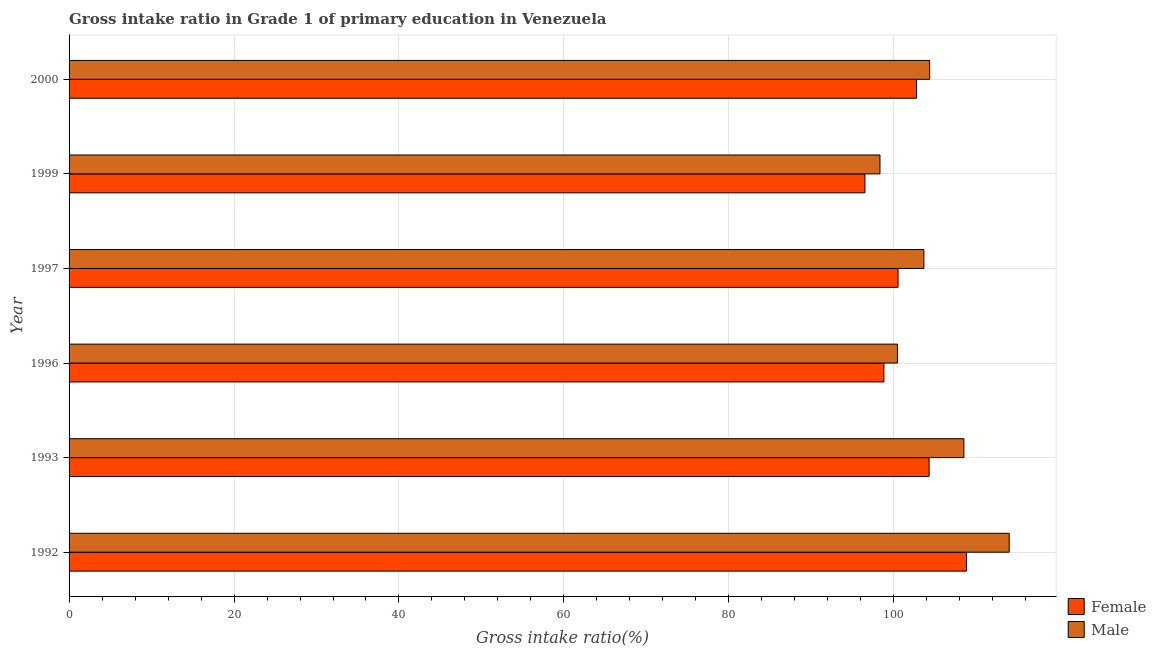How many different coloured bars are there?
Ensure brevity in your answer.  2. How many groups of bars are there?
Your answer should be compact. 6. Are the number of bars per tick equal to the number of legend labels?
Your answer should be compact. Yes. Are the number of bars on each tick of the Y-axis equal?
Give a very brief answer. Yes. What is the gross intake ratio(female) in 1993?
Make the answer very short. 104.27. Across all years, what is the maximum gross intake ratio(male)?
Give a very brief answer. 113.99. Across all years, what is the minimum gross intake ratio(male)?
Provide a succinct answer. 98.32. What is the total gross intake ratio(female) in the graph?
Offer a very short reply. 611.63. What is the difference between the gross intake ratio(male) in 1996 and that in 1997?
Offer a very short reply. -3.21. What is the difference between the gross intake ratio(male) in 1999 and the gross intake ratio(female) in 1992?
Provide a succinct answer. -10.48. What is the average gross intake ratio(female) per year?
Offer a very short reply. 101.94. In the year 2000, what is the difference between the gross intake ratio(male) and gross intake ratio(female)?
Your answer should be compact. 1.59. In how many years, is the gross intake ratio(male) greater than 52 %?
Give a very brief answer. 6. What is the ratio of the gross intake ratio(female) in 1992 to that in 1997?
Your answer should be very brief. 1.08. Is the gross intake ratio(female) in 1992 less than that in 2000?
Offer a terse response. No. What is the difference between the highest and the second highest gross intake ratio(female)?
Your response must be concise. 4.53. What is the difference between the highest and the lowest gross intake ratio(female)?
Your answer should be very brief. 12.31. In how many years, is the gross intake ratio(male) greater than the average gross intake ratio(male) taken over all years?
Your answer should be compact. 2. Is the sum of the gross intake ratio(female) in 1999 and 2000 greater than the maximum gross intake ratio(male) across all years?
Your answer should be compact. Yes. What does the 1st bar from the top in 1992 represents?
Your response must be concise. Male. What does the 2nd bar from the bottom in 1999 represents?
Offer a very short reply. Male. How many bars are there?
Give a very brief answer. 12. How many years are there in the graph?
Make the answer very short. 6. Where does the legend appear in the graph?
Your response must be concise. Bottom right. How are the legend labels stacked?
Offer a terse response. Vertical. What is the title of the graph?
Offer a terse response. Gross intake ratio in Grade 1 of primary education in Venezuela. What is the label or title of the X-axis?
Make the answer very short. Gross intake ratio(%). What is the Gross intake ratio(%) in Female in 1992?
Give a very brief answer. 108.8. What is the Gross intake ratio(%) in Male in 1992?
Your answer should be very brief. 113.99. What is the Gross intake ratio(%) in Female in 1993?
Give a very brief answer. 104.27. What is the Gross intake ratio(%) of Male in 1993?
Offer a terse response. 108.49. What is the Gross intake ratio(%) of Female in 1996?
Your answer should be very brief. 98.8. What is the Gross intake ratio(%) of Male in 1996?
Keep it short and to the point. 100.44. What is the Gross intake ratio(%) of Female in 1997?
Your answer should be very brief. 100.51. What is the Gross intake ratio(%) in Male in 1997?
Keep it short and to the point. 103.64. What is the Gross intake ratio(%) in Female in 1999?
Your answer should be compact. 96.5. What is the Gross intake ratio(%) in Male in 1999?
Provide a succinct answer. 98.32. What is the Gross intake ratio(%) of Female in 2000?
Your answer should be compact. 102.75. What is the Gross intake ratio(%) of Male in 2000?
Provide a succinct answer. 104.34. Across all years, what is the maximum Gross intake ratio(%) in Female?
Offer a terse response. 108.8. Across all years, what is the maximum Gross intake ratio(%) of Male?
Your response must be concise. 113.99. Across all years, what is the minimum Gross intake ratio(%) in Female?
Your answer should be very brief. 96.5. Across all years, what is the minimum Gross intake ratio(%) in Male?
Provide a short and direct response. 98.32. What is the total Gross intake ratio(%) of Female in the graph?
Make the answer very short. 611.63. What is the total Gross intake ratio(%) in Male in the graph?
Make the answer very short. 629.22. What is the difference between the Gross intake ratio(%) in Female in 1992 and that in 1993?
Offer a very short reply. 4.53. What is the difference between the Gross intake ratio(%) of Male in 1992 and that in 1993?
Offer a terse response. 5.49. What is the difference between the Gross intake ratio(%) in Female in 1992 and that in 1996?
Offer a terse response. 10.01. What is the difference between the Gross intake ratio(%) of Male in 1992 and that in 1996?
Offer a very short reply. 13.55. What is the difference between the Gross intake ratio(%) in Female in 1992 and that in 1997?
Make the answer very short. 8.29. What is the difference between the Gross intake ratio(%) in Male in 1992 and that in 1997?
Your answer should be compact. 10.34. What is the difference between the Gross intake ratio(%) of Female in 1992 and that in 1999?
Your answer should be compact. 12.31. What is the difference between the Gross intake ratio(%) in Male in 1992 and that in 1999?
Offer a very short reply. 15.67. What is the difference between the Gross intake ratio(%) in Female in 1992 and that in 2000?
Your answer should be compact. 6.05. What is the difference between the Gross intake ratio(%) of Male in 1992 and that in 2000?
Make the answer very short. 9.65. What is the difference between the Gross intake ratio(%) of Female in 1993 and that in 1996?
Provide a succinct answer. 5.48. What is the difference between the Gross intake ratio(%) of Male in 1993 and that in 1996?
Offer a very short reply. 8.06. What is the difference between the Gross intake ratio(%) of Female in 1993 and that in 1997?
Your response must be concise. 3.76. What is the difference between the Gross intake ratio(%) in Male in 1993 and that in 1997?
Offer a terse response. 4.85. What is the difference between the Gross intake ratio(%) in Female in 1993 and that in 1999?
Offer a terse response. 7.78. What is the difference between the Gross intake ratio(%) in Male in 1993 and that in 1999?
Give a very brief answer. 10.18. What is the difference between the Gross intake ratio(%) in Female in 1993 and that in 2000?
Your response must be concise. 1.52. What is the difference between the Gross intake ratio(%) of Male in 1993 and that in 2000?
Ensure brevity in your answer.  4.15. What is the difference between the Gross intake ratio(%) of Female in 1996 and that in 1997?
Keep it short and to the point. -1.71. What is the difference between the Gross intake ratio(%) in Male in 1996 and that in 1997?
Provide a succinct answer. -3.21. What is the difference between the Gross intake ratio(%) of Female in 1996 and that in 1999?
Make the answer very short. 2.3. What is the difference between the Gross intake ratio(%) in Male in 1996 and that in 1999?
Provide a short and direct response. 2.12. What is the difference between the Gross intake ratio(%) in Female in 1996 and that in 2000?
Your answer should be very brief. -3.95. What is the difference between the Gross intake ratio(%) of Male in 1996 and that in 2000?
Provide a short and direct response. -3.91. What is the difference between the Gross intake ratio(%) in Female in 1997 and that in 1999?
Keep it short and to the point. 4.01. What is the difference between the Gross intake ratio(%) in Male in 1997 and that in 1999?
Your answer should be compact. 5.32. What is the difference between the Gross intake ratio(%) in Female in 1997 and that in 2000?
Your answer should be compact. -2.24. What is the difference between the Gross intake ratio(%) of Male in 1997 and that in 2000?
Offer a terse response. -0.7. What is the difference between the Gross intake ratio(%) of Female in 1999 and that in 2000?
Your response must be concise. -6.25. What is the difference between the Gross intake ratio(%) in Male in 1999 and that in 2000?
Provide a succinct answer. -6.02. What is the difference between the Gross intake ratio(%) in Female in 1992 and the Gross intake ratio(%) in Male in 1993?
Keep it short and to the point. 0.31. What is the difference between the Gross intake ratio(%) of Female in 1992 and the Gross intake ratio(%) of Male in 1996?
Keep it short and to the point. 8.37. What is the difference between the Gross intake ratio(%) in Female in 1992 and the Gross intake ratio(%) in Male in 1997?
Your answer should be very brief. 5.16. What is the difference between the Gross intake ratio(%) of Female in 1992 and the Gross intake ratio(%) of Male in 1999?
Your answer should be compact. 10.48. What is the difference between the Gross intake ratio(%) in Female in 1992 and the Gross intake ratio(%) in Male in 2000?
Your answer should be compact. 4.46. What is the difference between the Gross intake ratio(%) in Female in 1993 and the Gross intake ratio(%) in Male in 1996?
Provide a succinct answer. 3.84. What is the difference between the Gross intake ratio(%) in Female in 1993 and the Gross intake ratio(%) in Male in 1997?
Offer a terse response. 0.63. What is the difference between the Gross intake ratio(%) of Female in 1993 and the Gross intake ratio(%) of Male in 1999?
Your answer should be very brief. 5.95. What is the difference between the Gross intake ratio(%) of Female in 1993 and the Gross intake ratio(%) of Male in 2000?
Make the answer very short. -0.07. What is the difference between the Gross intake ratio(%) in Female in 1996 and the Gross intake ratio(%) in Male in 1997?
Ensure brevity in your answer.  -4.85. What is the difference between the Gross intake ratio(%) in Female in 1996 and the Gross intake ratio(%) in Male in 1999?
Keep it short and to the point. 0.48. What is the difference between the Gross intake ratio(%) in Female in 1996 and the Gross intake ratio(%) in Male in 2000?
Your answer should be compact. -5.54. What is the difference between the Gross intake ratio(%) of Female in 1997 and the Gross intake ratio(%) of Male in 1999?
Your answer should be very brief. 2.19. What is the difference between the Gross intake ratio(%) of Female in 1997 and the Gross intake ratio(%) of Male in 2000?
Ensure brevity in your answer.  -3.83. What is the difference between the Gross intake ratio(%) in Female in 1999 and the Gross intake ratio(%) in Male in 2000?
Provide a succinct answer. -7.85. What is the average Gross intake ratio(%) in Female per year?
Your answer should be very brief. 101.94. What is the average Gross intake ratio(%) of Male per year?
Ensure brevity in your answer.  104.87. In the year 1992, what is the difference between the Gross intake ratio(%) of Female and Gross intake ratio(%) of Male?
Give a very brief answer. -5.18. In the year 1993, what is the difference between the Gross intake ratio(%) in Female and Gross intake ratio(%) in Male?
Your answer should be very brief. -4.22. In the year 1996, what is the difference between the Gross intake ratio(%) in Female and Gross intake ratio(%) in Male?
Offer a terse response. -1.64. In the year 1997, what is the difference between the Gross intake ratio(%) of Female and Gross intake ratio(%) of Male?
Your response must be concise. -3.13. In the year 1999, what is the difference between the Gross intake ratio(%) of Female and Gross intake ratio(%) of Male?
Your answer should be very brief. -1.82. In the year 2000, what is the difference between the Gross intake ratio(%) of Female and Gross intake ratio(%) of Male?
Your answer should be compact. -1.59. What is the ratio of the Gross intake ratio(%) of Female in 1992 to that in 1993?
Offer a very short reply. 1.04. What is the ratio of the Gross intake ratio(%) of Male in 1992 to that in 1993?
Keep it short and to the point. 1.05. What is the ratio of the Gross intake ratio(%) of Female in 1992 to that in 1996?
Your response must be concise. 1.1. What is the ratio of the Gross intake ratio(%) in Male in 1992 to that in 1996?
Your answer should be compact. 1.13. What is the ratio of the Gross intake ratio(%) of Female in 1992 to that in 1997?
Offer a very short reply. 1.08. What is the ratio of the Gross intake ratio(%) in Male in 1992 to that in 1997?
Provide a succinct answer. 1.1. What is the ratio of the Gross intake ratio(%) of Female in 1992 to that in 1999?
Your response must be concise. 1.13. What is the ratio of the Gross intake ratio(%) in Male in 1992 to that in 1999?
Offer a very short reply. 1.16. What is the ratio of the Gross intake ratio(%) of Female in 1992 to that in 2000?
Your answer should be very brief. 1.06. What is the ratio of the Gross intake ratio(%) in Male in 1992 to that in 2000?
Offer a terse response. 1.09. What is the ratio of the Gross intake ratio(%) in Female in 1993 to that in 1996?
Ensure brevity in your answer.  1.06. What is the ratio of the Gross intake ratio(%) of Male in 1993 to that in 1996?
Your answer should be very brief. 1.08. What is the ratio of the Gross intake ratio(%) in Female in 1993 to that in 1997?
Your answer should be very brief. 1.04. What is the ratio of the Gross intake ratio(%) in Male in 1993 to that in 1997?
Provide a succinct answer. 1.05. What is the ratio of the Gross intake ratio(%) of Female in 1993 to that in 1999?
Ensure brevity in your answer.  1.08. What is the ratio of the Gross intake ratio(%) of Male in 1993 to that in 1999?
Ensure brevity in your answer.  1.1. What is the ratio of the Gross intake ratio(%) in Female in 1993 to that in 2000?
Your answer should be compact. 1.01. What is the ratio of the Gross intake ratio(%) in Male in 1993 to that in 2000?
Your answer should be very brief. 1.04. What is the ratio of the Gross intake ratio(%) in Female in 1996 to that in 1997?
Your answer should be very brief. 0.98. What is the ratio of the Gross intake ratio(%) in Male in 1996 to that in 1997?
Keep it short and to the point. 0.97. What is the ratio of the Gross intake ratio(%) in Female in 1996 to that in 1999?
Offer a terse response. 1.02. What is the ratio of the Gross intake ratio(%) in Male in 1996 to that in 1999?
Make the answer very short. 1.02. What is the ratio of the Gross intake ratio(%) in Female in 1996 to that in 2000?
Provide a short and direct response. 0.96. What is the ratio of the Gross intake ratio(%) in Male in 1996 to that in 2000?
Make the answer very short. 0.96. What is the ratio of the Gross intake ratio(%) of Female in 1997 to that in 1999?
Make the answer very short. 1.04. What is the ratio of the Gross intake ratio(%) of Male in 1997 to that in 1999?
Give a very brief answer. 1.05. What is the ratio of the Gross intake ratio(%) in Female in 1997 to that in 2000?
Make the answer very short. 0.98. What is the ratio of the Gross intake ratio(%) of Female in 1999 to that in 2000?
Keep it short and to the point. 0.94. What is the ratio of the Gross intake ratio(%) in Male in 1999 to that in 2000?
Your answer should be compact. 0.94. What is the difference between the highest and the second highest Gross intake ratio(%) of Female?
Give a very brief answer. 4.53. What is the difference between the highest and the second highest Gross intake ratio(%) of Male?
Provide a succinct answer. 5.49. What is the difference between the highest and the lowest Gross intake ratio(%) in Female?
Give a very brief answer. 12.31. What is the difference between the highest and the lowest Gross intake ratio(%) of Male?
Offer a terse response. 15.67. 